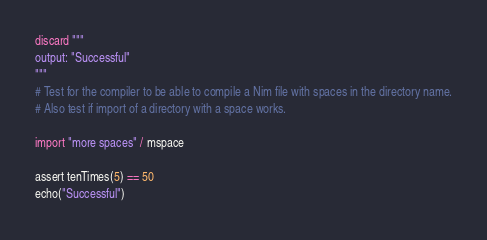Convert code to text. <code><loc_0><loc_0><loc_500><loc_500><_Nim_>discard """
output: "Successful"
"""
# Test for the compiler to be able to compile a Nim file with spaces in the directory name.
# Also test if import of a directory with a space works.

import "more spaces" / mspace

assert tenTimes(5) == 50
echo("Successful")
</code> 